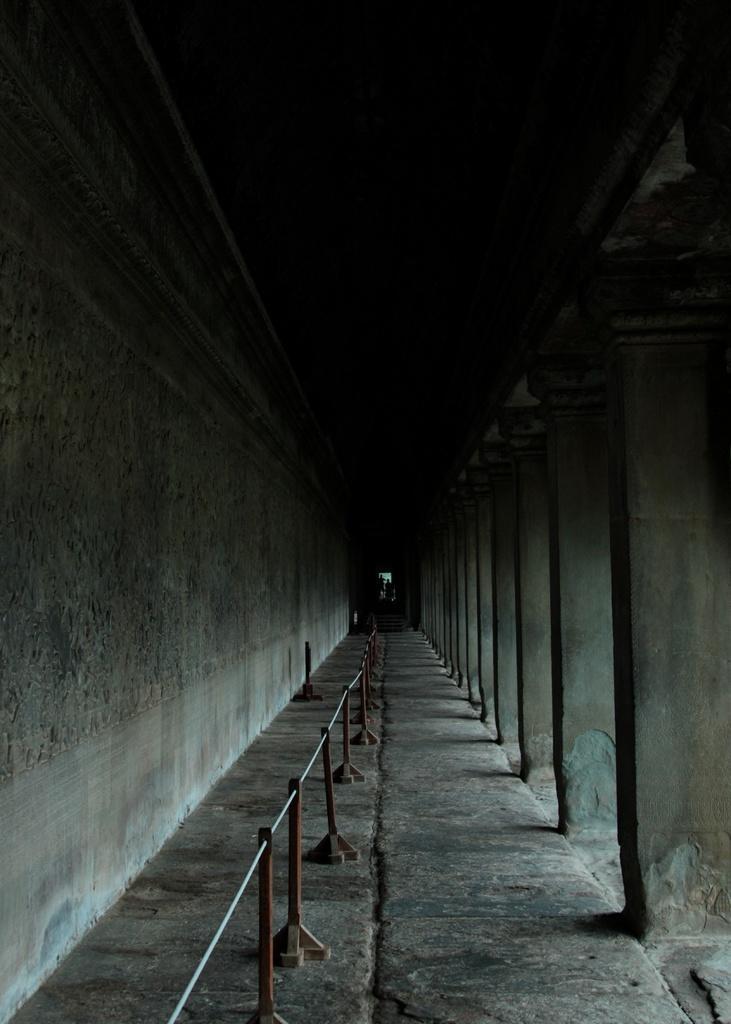How would you summarize this image in a sentence or two? In this image we can see railing, floor, pillars and a wall. 